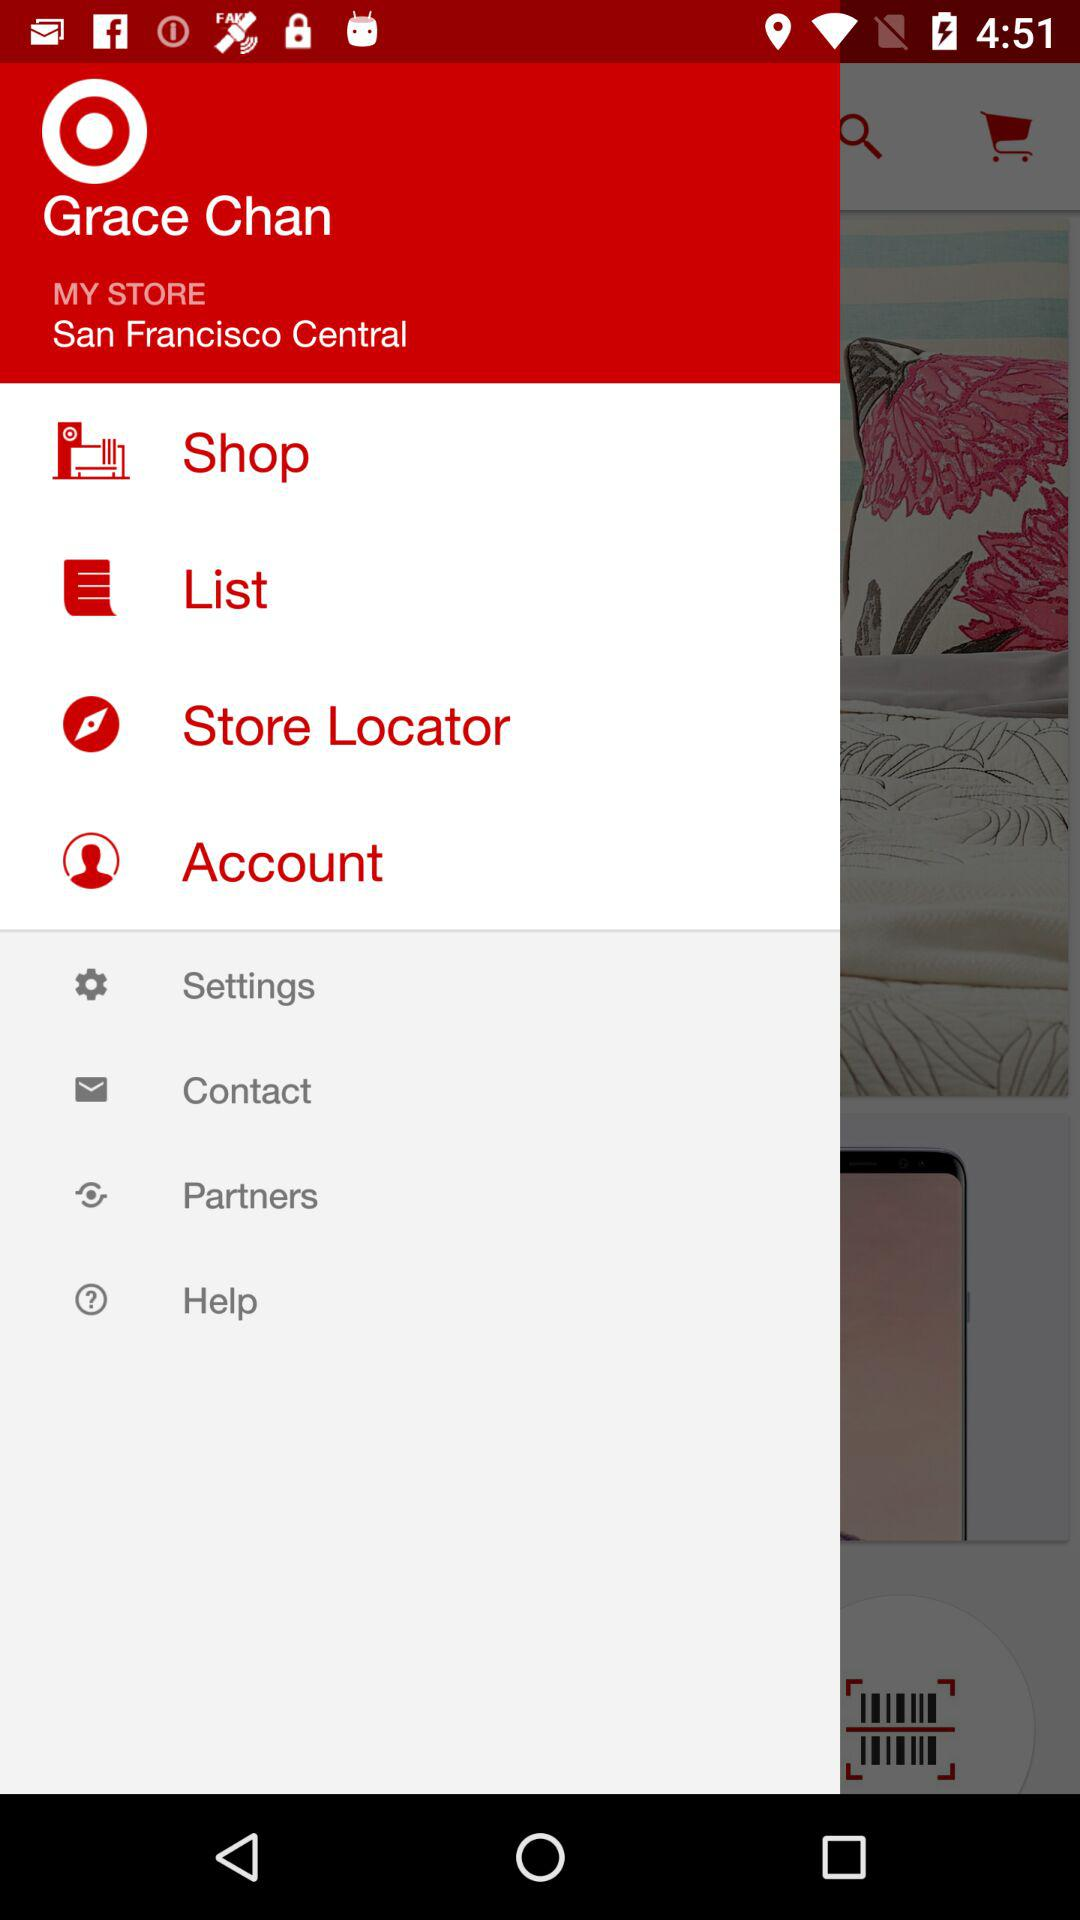What is the name? The name is Grace Chan. 